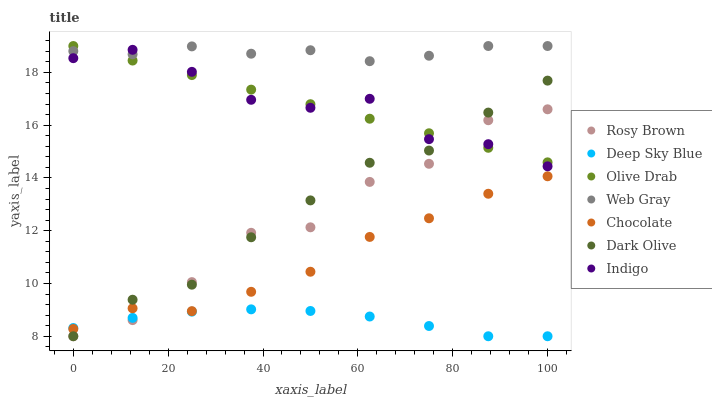Does Deep Sky Blue have the minimum area under the curve?
Answer yes or no. Yes. Does Web Gray have the maximum area under the curve?
Answer yes or no. Yes. Does Indigo have the minimum area under the curve?
Answer yes or no. No. Does Indigo have the maximum area under the curve?
Answer yes or no. No. Is Olive Drab the smoothest?
Answer yes or no. Yes. Is Rosy Brown the roughest?
Answer yes or no. Yes. Is Indigo the smoothest?
Answer yes or no. No. Is Indigo the roughest?
Answer yes or no. No. Does Rosy Brown have the lowest value?
Answer yes or no. Yes. Does Indigo have the lowest value?
Answer yes or no. No. Does Olive Drab have the highest value?
Answer yes or no. Yes. Does Indigo have the highest value?
Answer yes or no. No. Is Deep Sky Blue less than Olive Drab?
Answer yes or no. Yes. Is Web Gray greater than Rosy Brown?
Answer yes or no. Yes. Does Indigo intersect Olive Drab?
Answer yes or no. Yes. Is Indigo less than Olive Drab?
Answer yes or no. No. Is Indigo greater than Olive Drab?
Answer yes or no. No. Does Deep Sky Blue intersect Olive Drab?
Answer yes or no. No. 